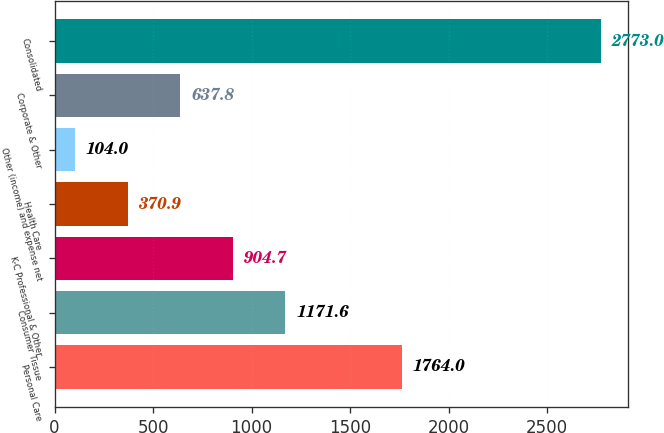Convert chart to OTSL. <chart><loc_0><loc_0><loc_500><loc_500><bar_chart><fcel>Personal Care<fcel>Consumer Tissue<fcel>K-C Professional & Other<fcel>Health Care<fcel>Other (income) and expense net<fcel>Corporate & Other<fcel>Consolidated<nl><fcel>1764<fcel>1171.6<fcel>904.7<fcel>370.9<fcel>104<fcel>637.8<fcel>2773<nl></chart> 